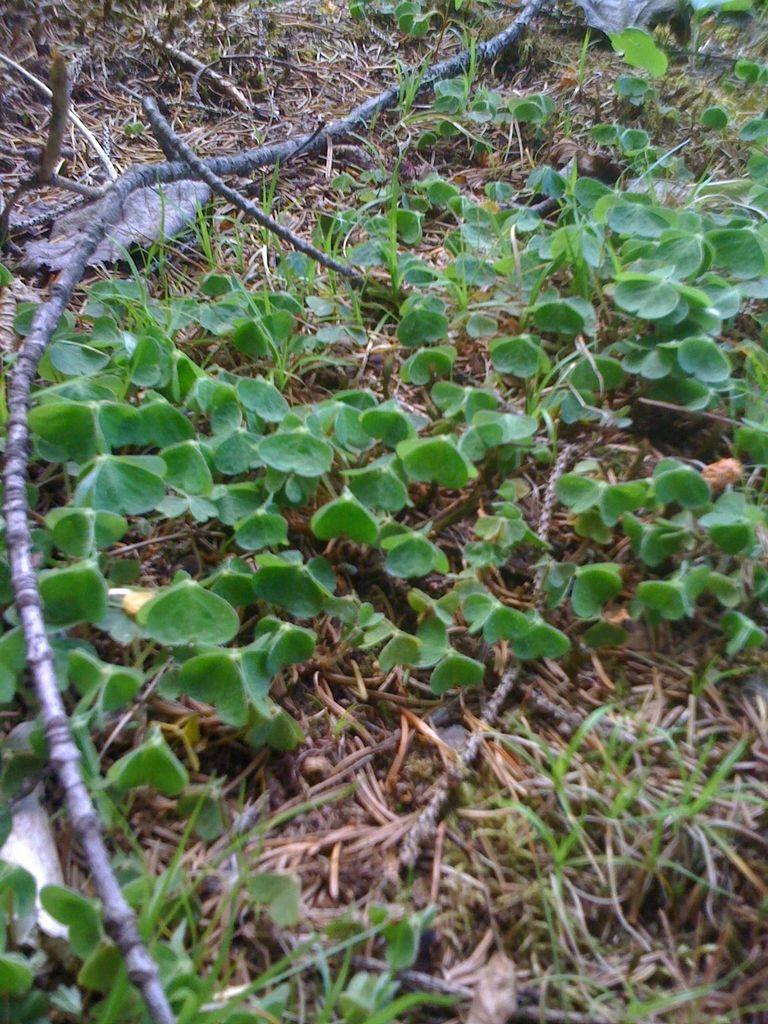What type of vegetation can be seen in the image? There is a group of plants and grass in the image. What else can be found on the ground in the image? Dried branches are on the ground in the image. What type of legal advice is the heart seeking from the brother in the image? There is no brother, heart, or legal advice present in the image; it features a group of plants, grass, and dried branches. 